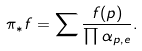<formula> <loc_0><loc_0><loc_500><loc_500>\pi _ { * } f = \sum \frac { f ( p ) } { \prod \alpha _ { p , e } } .</formula> 